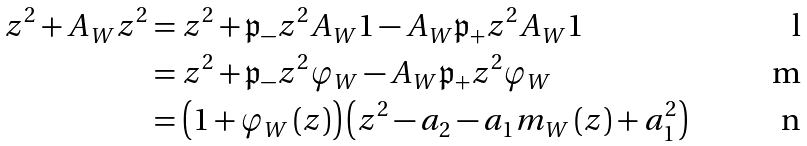Convert formula to latex. <formula><loc_0><loc_0><loc_500><loc_500>z ^ { 2 } + A _ { W } z ^ { 2 } & = z ^ { 2 } + \mathfrak { p } _ { - } z ^ { 2 } A _ { W } 1 - A _ { W } \mathfrak { p } _ { + } z ^ { 2 } A _ { W } 1 \\ & = z ^ { 2 } + \mathfrak { p } _ { - } z ^ { 2 } \varphi _ { W } - A _ { W } \mathfrak { p } _ { + } z ^ { 2 } \varphi _ { W } \\ & = \left ( 1 + \varphi _ { W } \left ( z \right ) \right ) \left ( z ^ { 2 } - a _ { 2 } - a _ { 1 } m _ { W } \left ( z \right ) + a _ { 1 } ^ { 2 } \right )</formula> 